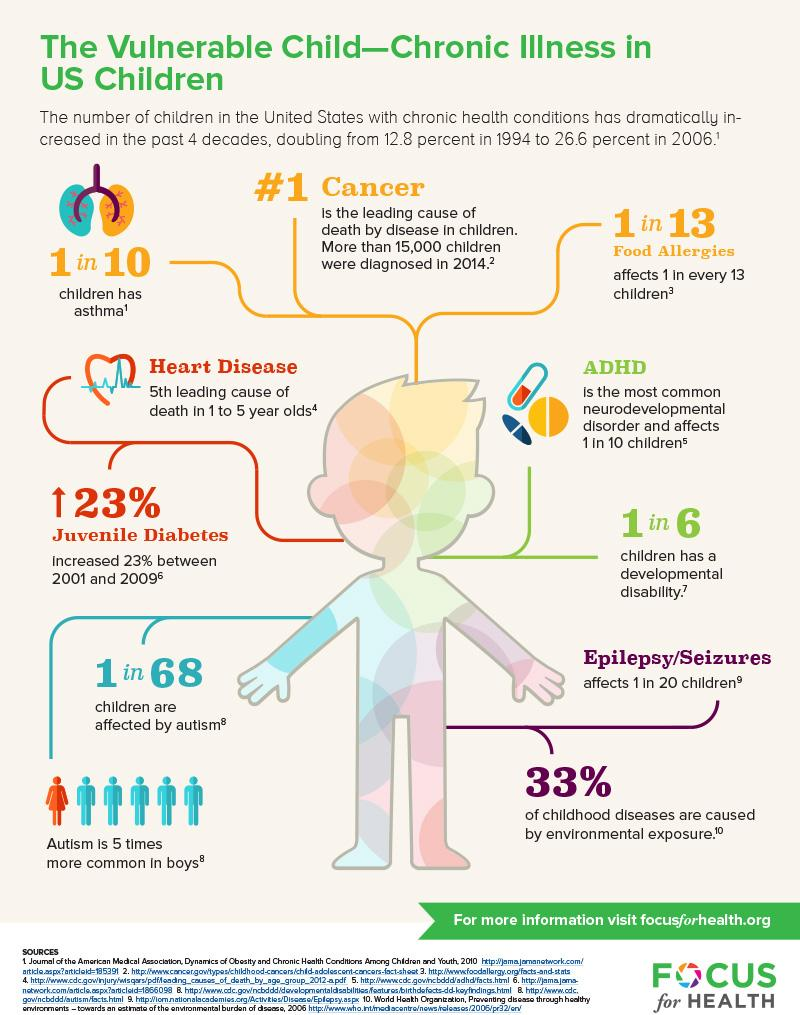Mention a couple of crucial points in this snapshot. Out of 10 children, 9 have no asthma. Out of the 6 children, 5 of them have a developmental disability. Out of the 68 children, how many are not affected by autism? 67 of them do not have autism. According to recent studies, approximately 67% of childhood diseases are not caused by environmental exposure. 